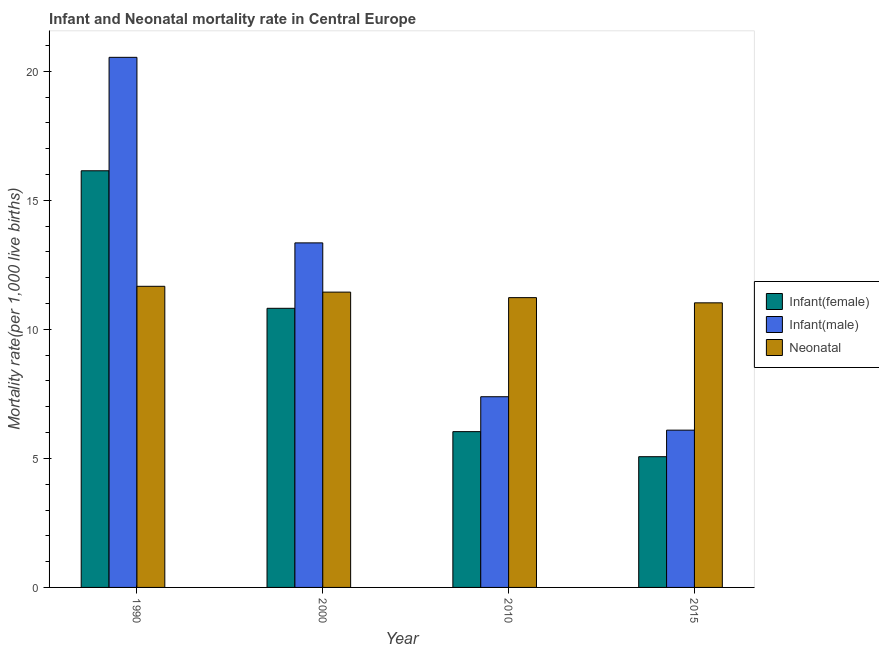How many groups of bars are there?
Make the answer very short. 4. Are the number of bars on each tick of the X-axis equal?
Your response must be concise. Yes. How many bars are there on the 1st tick from the right?
Offer a terse response. 3. What is the infant mortality rate(male) in 2015?
Keep it short and to the point. 6.09. Across all years, what is the maximum neonatal mortality rate?
Offer a very short reply. 11.67. Across all years, what is the minimum neonatal mortality rate?
Offer a very short reply. 11.03. In which year was the infant mortality rate(female) minimum?
Offer a terse response. 2015. What is the total infant mortality rate(male) in the graph?
Keep it short and to the point. 47.37. What is the difference between the infant mortality rate(female) in 2000 and that in 2010?
Your answer should be very brief. 4.78. What is the difference between the infant mortality rate(male) in 2000 and the neonatal mortality rate in 1990?
Keep it short and to the point. -7.19. What is the average infant mortality rate(female) per year?
Your answer should be very brief. 9.52. In the year 1990, what is the difference between the neonatal mortality rate and infant mortality rate(male)?
Your answer should be very brief. 0. What is the ratio of the infant mortality rate(male) in 2000 to that in 2010?
Your answer should be very brief. 1.81. Is the difference between the infant mortality rate(female) in 2010 and 2015 greater than the difference between the neonatal mortality rate in 2010 and 2015?
Provide a succinct answer. No. What is the difference between the highest and the second highest infant mortality rate(female)?
Ensure brevity in your answer.  5.33. What is the difference between the highest and the lowest neonatal mortality rate?
Your answer should be very brief. 0.64. What does the 2nd bar from the left in 2015 represents?
Keep it short and to the point. Infant(male). What does the 2nd bar from the right in 1990 represents?
Offer a very short reply. Infant(male). Is it the case that in every year, the sum of the infant mortality rate(female) and infant mortality rate(male) is greater than the neonatal mortality rate?
Keep it short and to the point. Yes. What is the difference between two consecutive major ticks on the Y-axis?
Give a very brief answer. 5. Are the values on the major ticks of Y-axis written in scientific E-notation?
Your answer should be very brief. No. Does the graph contain any zero values?
Provide a short and direct response. No. How are the legend labels stacked?
Provide a short and direct response. Vertical. What is the title of the graph?
Your answer should be very brief. Infant and Neonatal mortality rate in Central Europe. Does "Social Protection and Labor" appear as one of the legend labels in the graph?
Give a very brief answer. No. What is the label or title of the X-axis?
Make the answer very short. Year. What is the label or title of the Y-axis?
Provide a succinct answer. Mortality rate(per 1,0 live births). What is the Mortality rate(per 1,000 live births) in Infant(female) in 1990?
Ensure brevity in your answer.  16.14. What is the Mortality rate(per 1,000 live births) of Infant(male) in 1990?
Give a very brief answer. 20.54. What is the Mortality rate(per 1,000 live births) of Neonatal  in 1990?
Your response must be concise. 11.67. What is the Mortality rate(per 1,000 live births) in Infant(female) in 2000?
Make the answer very short. 10.82. What is the Mortality rate(per 1,000 live births) of Infant(male) in 2000?
Your answer should be compact. 13.35. What is the Mortality rate(per 1,000 live births) of Neonatal  in 2000?
Give a very brief answer. 11.44. What is the Mortality rate(per 1,000 live births) in Infant(female) in 2010?
Provide a succinct answer. 6.04. What is the Mortality rate(per 1,000 live births) in Infant(male) in 2010?
Make the answer very short. 7.39. What is the Mortality rate(per 1,000 live births) of Neonatal  in 2010?
Make the answer very short. 11.23. What is the Mortality rate(per 1,000 live births) in Infant(female) in 2015?
Keep it short and to the point. 5.07. What is the Mortality rate(per 1,000 live births) of Infant(male) in 2015?
Ensure brevity in your answer.  6.09. What is the Mortality rate(per 1,000 live births) in Neonatal  in 2015?
Provide a short and direct response. 11.03. Across all years, what is the maximum Mortality rate(per 1,000 live births) in Infant(female)?
Provide a short and direct response. 16.14. Across all years, what is the maximum Mortality rate(per 1,000 live births) of Infant(male)?
Provide a succinct answer. 20.54. Across all years, what is the maximum Mortality rate(per 1,000 live births) of Neonatal ?
Give a very brief answer. 11.67. Across all years, what is the minimum Mortality rate(per 1,000 live births) of Infant(female)?
Provide a short and direct response. 5.07. Across all years, what is the minimum Mortality rate(per 1,000 live births) in Infant(male)?
Your answer should be very brief. 6.09. Across all years, what is the minimum Mortality rate(per 1,000 live births) of Neonatal ?
Provide a short and direct response. 11.03. What is the total Mortality rate(per 1,000 live births) in Infant(female) in the graph?
Ensure brevity in your answer.  38.06. What is the total Mortality rate(per 1,000 live births) in Infant(male) in the graph?
Your response must be concise. 47.37. What is the total Mortality rate(per 1,000 live births) in Neonatal  in the graph?
Your answer should be very brief. 45.37. What is the difference between the Mortality rate(per 1,000 live births) of Infant(female) in 1990 and that in 2000?
Ensure brevity in your answer.  5.33. What is the difference between the Mortality rate(per 1,000 live births) in Infant(male) in 1990 and that in 2000?
Keep it short and to the point. 7.19. What is the difference between the Mortality rate(per 1,000 live births) of Neonatal  in 1990 and that in 2000?
Ensure brevity in your answer.  0.23. What is the difference between the Mortality rate(per 1,000 live births) in Infant(female) in 1990 and that in 2010?
Ensure brevity in your answer.  10.11. What is the difference between the Mortality rate(per 1,000 live births) of Infant(male) in 1990 and that in 2010?
Keep it short and to the point. 13.15. What is the difference between the Mortality rate(per 1,000 live births) in Neonatal  in 1990 and that in 2010?
Your response must be concise. 0.44. What is the difference between the Mortality rate(per 1,000 live births) of Infant(female) in 1990 and that in 2015?
Make the answer very short. 11.08. What is the difference between the Mortality rate(per 1,000 live births) in Infant(male) in 1990 and that in 2015?
Give a very brief answer. 14.45. What is the difference between the Mortality rate(per 1,000 live births) of Neonatal  in 1990 and that in 2015?
Your answer should be compact. 0.64. What is the difference between the Mortality rate(per 1,000 live births) of Infant(female) in 2000 and that in 2010?
Keep it short and to the point. 4.78. What is the difference between the Mortality rate(per 1,000 live births) of Infant(male) in 2000 and that in 2010?
Offer a very short reply. 5.96. What is the difference between the Mortality rate(per 1,000 live births) of Neonatal  in 2000 and that in 2010?
Your answer should be compact. 0.21. What is the difference between the Mortality rate(per 1,000 live births) in Infant(female) in 2000 and that in 2015?
Your answer should be compact. 5.75. What is the difference between the Mortality rate(per 1,000 live births) in Infant(male) in 2000 and that in 2015?
Keep it short and to the point. 7.26. What is the difference between the Mortality rate(per 1,000 live births) in Neonatal  in 2000 and that in 2015?
Provide a succinct answer. 0.42. What is the difference between the Mortality rate(per 1,000 live births) of Infant(female) in 2010 and that in 2015?
Provide a short and direct response. 0.97. What is the difference between the Mortality rate(per 1,000 live births) of Infant(male) in 2010 and that in 2015?
Your response must be concise. 1.29. What is the difference between the Mortality rate(per 1,000 live births) of Neonatal  in 2010 and that in 2015?
Provide a succinct answer. 0.2. What is the difference between the Mortality rate(per 1,000 live births) of Infant(female) in 1990 and the Mortality rate(per 1,000 live births) of Infant(male) in 2000?
Offer a terse response. 2.79. What is the difference between the Mortality rate(per 1,000 live births) of Infant(female) in 1990 and the Mortality rate(per 1,000 live births) of Neonatal  in 2000?
Keep it short and to the point. 4.7. What is the difference between the Mortality rate(per 1,000 live births) in Infant(male) in 1990 and the Mortality rate(per 1,000 live births) in Neonatal  in 2000?
Provide a short and direct response. 9.1. What is the difference between the Mortality rate(per 1,000 live births) of Infant(female) in 1990 and the Mortality rate(per 1,000 live births) of Infant(male) in 2010?
Keep it short and to the point. 8.76. What is the difference between the Mortality rate(per 1,000 live births) in Infant(female) in 1990 and the Mortality rate(per 1,000 live births) in Neonatal  in 2010?
Provide a short and direct response. 4.92. What is the difference between the Mortality rate(per 1,000 live births) of Infant(male) in 1990 and the Mortality rate(per 1,000 live births) of Neonatal  in 2010?
Offer a very short reply. 9.31. What is the difference between the Mortality rate(per 1,000 live births) of Infant(female) in 1990 and the Mortality rate(per 1,000 live births) of Infant(male) in 2015?
Provide a short and direct response. 10.05. What is the difference between the Mortality rate(per 1,000 live births) in Infant(female) in 1990 and the Mortality rate(per 1,000 live births) in Neonatal  in 2015?
Your response must be concise. 5.12. What is the difference between the Mortality rate(per 1,000 live births) in Infant(male) in 1990 and the Mortality rate(per 1,000 live births) in Neonatal  in 2015?
Provide a succinct answer. 9.51. What is the difference between the Mortality rate(per 1,000 live births) of Infant(female) in 2000 and the Mortality rate(per 1,000 live births) of Infant(male) in 2010?
Keep it short and to the point. 3.43. What is the difference between the Mortality rate(per 1,000 live births) of Infant(female) in 2000 and the Mortality rate(per 1,000 live births) of Neonatal  in 2010?
Make the answer very short. -0.41. What is the difference between the Mortality rate(per 1,000 live births) of Infant(male) in 2000 and the Mortality rate(per 1,000 live births) of Neonatal  in 2010?
Your response must be concise. 2.12. What is the difference between the Mortality rate(per 1,000 live births) of Infant(female) in 2000 and the Mortality rate(per 1,000 live births) of Infant(male) in 2015?
Offer a terse response. 4.72. What is the difference between the Mortality rate(per 1,000 live births) in Infant(female) in 2000 and the Mortality rate(per 1,000 live births) in Neonatal  in 2015?
Ensure brevity in your answer.  -0.21. What is the difference between the Mortality rate(per 1,000 live births) in Infant(male) in 2000 and the Mortality rate(per 1,000 live births) in Neonatal  in 2015?
Make the answer very short. 2.32. What is the difference between the Mortality rate(per 1,000 live births) of Infant(female) in 2010 and the Mortality rate(per 1,000 live births) of Infant(male) in 2015?
Your response must be concise. -0.06. What is the difference between the Mortality rate(per 1,000 live births) of Infant(female) in 2010 and the Mortality rate(per 1,000 live births) of Neonatal  in 2015?
Offer a very short reply. -4.99. What is the difference between the Mortality rate(per 1,000 live births) of Infant(male) in 2010 and the Mortality rate(per 1,000 live births) of Neonatal  in 2015?
Provide a succinct answer. -3.64. What is the average Mortality rate(per 1,000 live births) in Infant(female) per year?
Your response must be concise. 9.52. What is the average Mortality rate(per 1,000 live births) of Infant(male) per year?
Provide a short and direct response. 11.84. What is the average Mortality rate(per 1,000 live births) of Neonatal  per year?
Provide a succinct answer. 11.34. In the year 1990, what is the difference between the Mortality rate(per 1,000 live births) in Infant(female) and Mortality rate(per 1,000 live births) in Infant(male)?
Provide a succinct answer. -4.4. In the year 1990, what is the difference between the Mortality rate(per 1,000 live births) of Infant(female) and Mortality rate(per 1,000 live births) of Neonatal ?
Offer a very short reply. 4.48. In the year 1990, what is the difference between the Mortality rate(per 1,000 live births) in Infant(male) and Mortality rate(per 1,000 live births) in Neonatal ?
Ensure brevity in your answer.  8.87. In the year 2000, what is the difference between the Mortality rate(per 1,000 live births) in Infant(female) and Mortality rate(per 1,000 live births) in Infant(male)?
Your answer should be compact. -2.54. In the year 2000, what is the difference between the Mortality rate(per 1,000 live births) in Infant(female) and Mortality rate(per 1,000 live births) in Neonatal ?
Provide a succinct answer. -0.63. In the year 2000, what is the difference between the Mortality rate(per 1,000 live births) of Infant(male) and Mortality rate(per 1,000 live births) of Neonatal ?
Offer a terse response. 1.91. In the year 2010, what is the difference between the Mortality rate(per 1,000 live births) of Infant(female) and Mortality rate(per 1,000 live births) of Infant(male)?
Keep it short and to the point. -1.35. In the year 2010, what is the difference between the Mortality rate(per 1,000 live births) in Infant(female) and Mortality rate(per 1,000 live births) in Neonatal ?
Keep it short and to the point. -5.19. In the year 2010, what is the difference between the Mortality rate(per 1,000 live births) of Infant(male) and Mortality rate(per 1,000 live births) of Neonatal ?
Provide a short and direct response. -3.84. In the year 2015, what is the difference between the Mortality rate(per 1,000 live births) of Infant(female) and Mortality rate(per 1,000 live births) of Infant(male)?
Keep it short and to the point. -1.03. In the year 2015, what is the difference between the Mortality rate(per 1,000 live births) in Infant(female) and Mortality rate(per 1,000 live births) in Neonatal ?
Keep it short and to the point. -5.96. In the year 2015, what is the difference between the Mortality rate(per 1,000 live births) in Infant(male) and Mortality rate(per 1,000 live births) in Neonatal ?
Ensure brevity in your answer.  -4.93. What is the ratio of the Mortality rate(per 1,000 live births) of Infant(female) in 1990 to that in 2000?
Your answer should be compact. 1.49. What is the ratio of the Mortality rate(per 1,000 live births) of Infant(male) in 1990 to that in 2000?
Your answer should be compact. 1.54. What is the ratio of the Mortality rate(per 1,000 live births) in Neonatal  in 1990 to that in 2000?
Your response must be concise. 1.02. What is the ratio of the Mortality rate(per 1,000 live births) in Infant(female) in 1990 to that in 2010?
Provide a succinct answer. 2.67. What is the ratio of the Mortality rate(per 1,000 live births) in Infant(male) in 1990 to that in 2010?
Make the answer very short. 2.78. What is the ratio of the Mortality rate(per 1,000 live births) in Neonatal  in 1990 to that in 2010?
Your answer should be compact. 1.04. What is the ratio of the Mortality rate(per 1,000 live births) of Infant(female) in 1990 to that in 2015?
Ensure brevity in your answer.  3.19. What is the ratio of the Mortality rate(per 1,000 live births) in Infant(male) in 1990 to that in 2015?
Offer a very short reply. 3.37. What is the ratio of the Mortality rate(per 1,000 live births) in Neonatal  in 1990 to that in 2015?
Offer a terse response. 1.06. What is the ratio of the Mortality rate(per 1,000 live births) of Infant(female) in 2000 to that in 2010?
Ensure brevity in your answer.  1.79. What is the ratio of the Mortality rate(per 1,000 live births) in Infant(male) in 2000 to that in 2010?
Ensure brevity in your answer.  1.81. What is the ratio of the Mortality rate(per 1,000 live births) of Infant(female) in 2000 to that in 2015?
Provide a succinct answer. 2.14. What is the ratio of the Mortality rate(per 1,000 live births) of Infant(male) in 2000 to that in 2015?
Offer a terse response. 2.19. What is the ratio of the Mortality rate(per 1,000 live births) in Neonatal  in 2000 to that in 2015?
Offer a very short reply. 1.04. What is the ratio of the Mortality rate(per 1,000 live births) in Infant(female) in 2010 to that in 2015?
Ensure brevity in your answer.  1.19. What is the ratio of the Mortality rate(per 1,000 live births) in Infant(male) in 2010 to that in 2015?
Your answer should be very brief. 1.21. What is the ratio of the Mortality rate(per 1,000 live births) of Neonatal  in 2010 to that in 2015?
Your answer should be very brief. 1.02. What is the difference between the highest and the second highest Mortality rate(per 1,000 live births) of Infant(female)?
Keep it short and to the point. 5.33. What is the difference between the highest and the second highest Mortality rate(per 1,000 live births) of Infant(male)?
Give a very brief answer. 7.19. What is the difference between the highest and the second highest Mortality rate(per 1,000 live births) in Neonatal ?
Your answer should be compact. 0.23. What is the difference between the highest and the lowest Mortality rate(per 1,000 live births) in Infant(female)?
Your answer should be very brief. 11.08. What is the difference between the highest and the lowest Mortality rate(per 1,000 live births) of Infant(male)?
Keep it short and to the point. 14.45. What is the difference between the highest and the lowest Mortality rate(per 1,000 live births) in Neonatal ?
Ensure brevity in your answer.  0.64. 